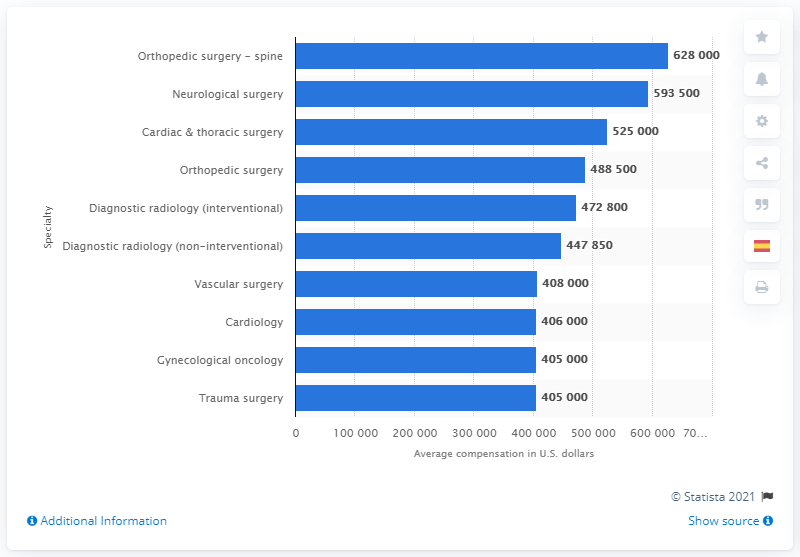Highlight a few significant elements in this photo. The average compensation for neurological surgery in 2013 was approximately 593,500. 